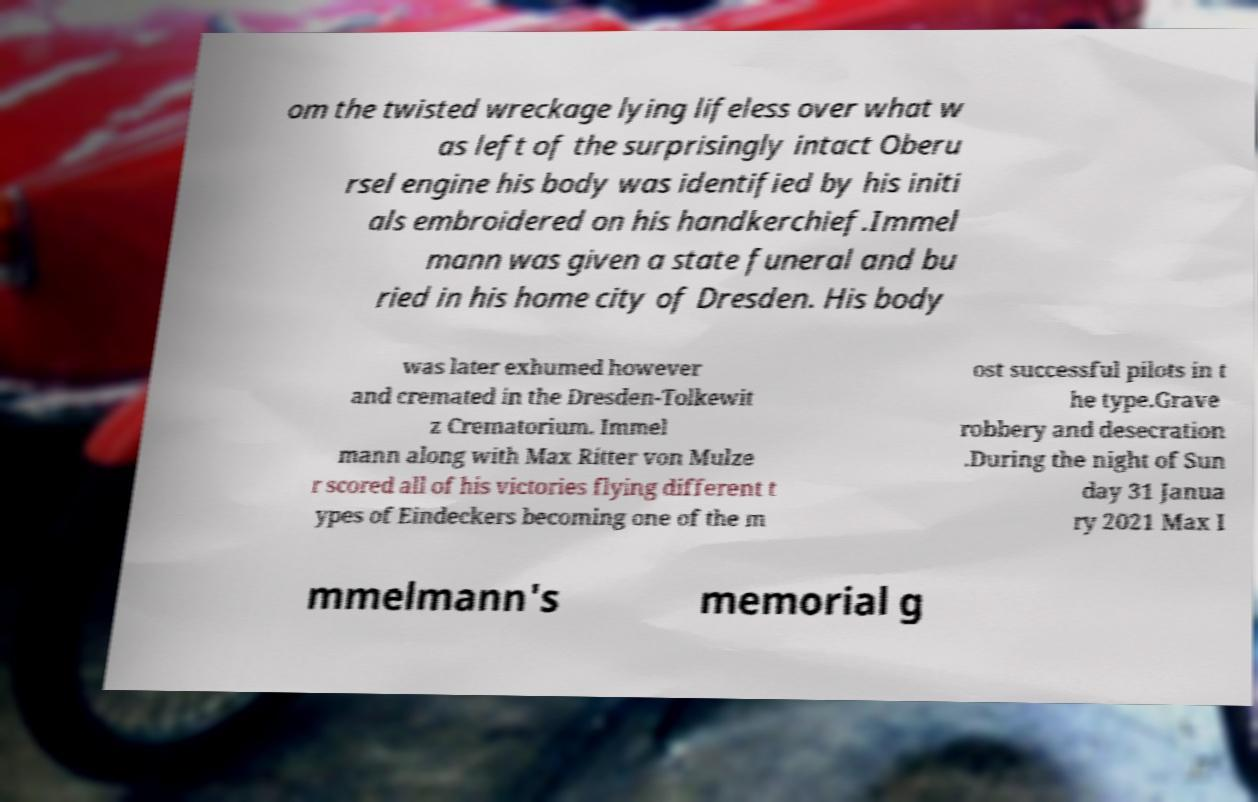Can you read and provide the text displayed in the image?This photo seems to have some interesting text. Can you extract and type it out for me? om the twisted wreckage lying lifeless over what w as left of the surprisingly intact Oberu rsel engine his body was identified by his initi als embroidered on his handkerchief.Immel mann was given a state funeral and bu ried in his home city of Dresden. His body was later exhumed however and cremated in the Dresden-Tolkewit z Crematorium. Immel mann along with Max Ritter von Mulze r scored all of his victories flying different t ypes of Eindeckers becoming one of the m ost successful pilots in t he type.Grave robbery and desecration .During the night of Sun day 31 Janua ry 2021 Max I mmelmann's memorial g 